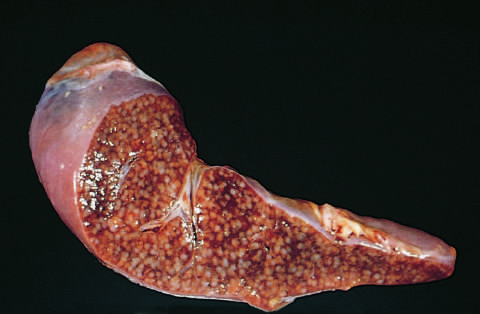what shows numerous gray-white granulomas?
Answer the question using a single word or phrase. The cut surface 